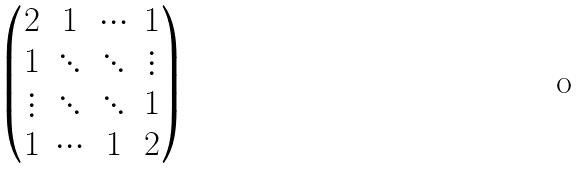<formula> <loc_0><loc_0><loc_500><loc_500>\begin{pmatrix} 2 & 1 & \cdots & 1 \\ 1 & \ddots & \ddots & \vdots \\ \vdots & \ddots & \ddots & 1 \\ 1 & \cdots & 1 & 2 \\ \end{pmatrix}</formula> 